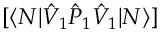<formula> <loc_0><loc_0><loc_500><loc_500>[ \langle N | \hat { V } _ { 1 } \hat { P } _ { 1 } \hat { V } _ { 1 } | N \rangle ]</formula> 